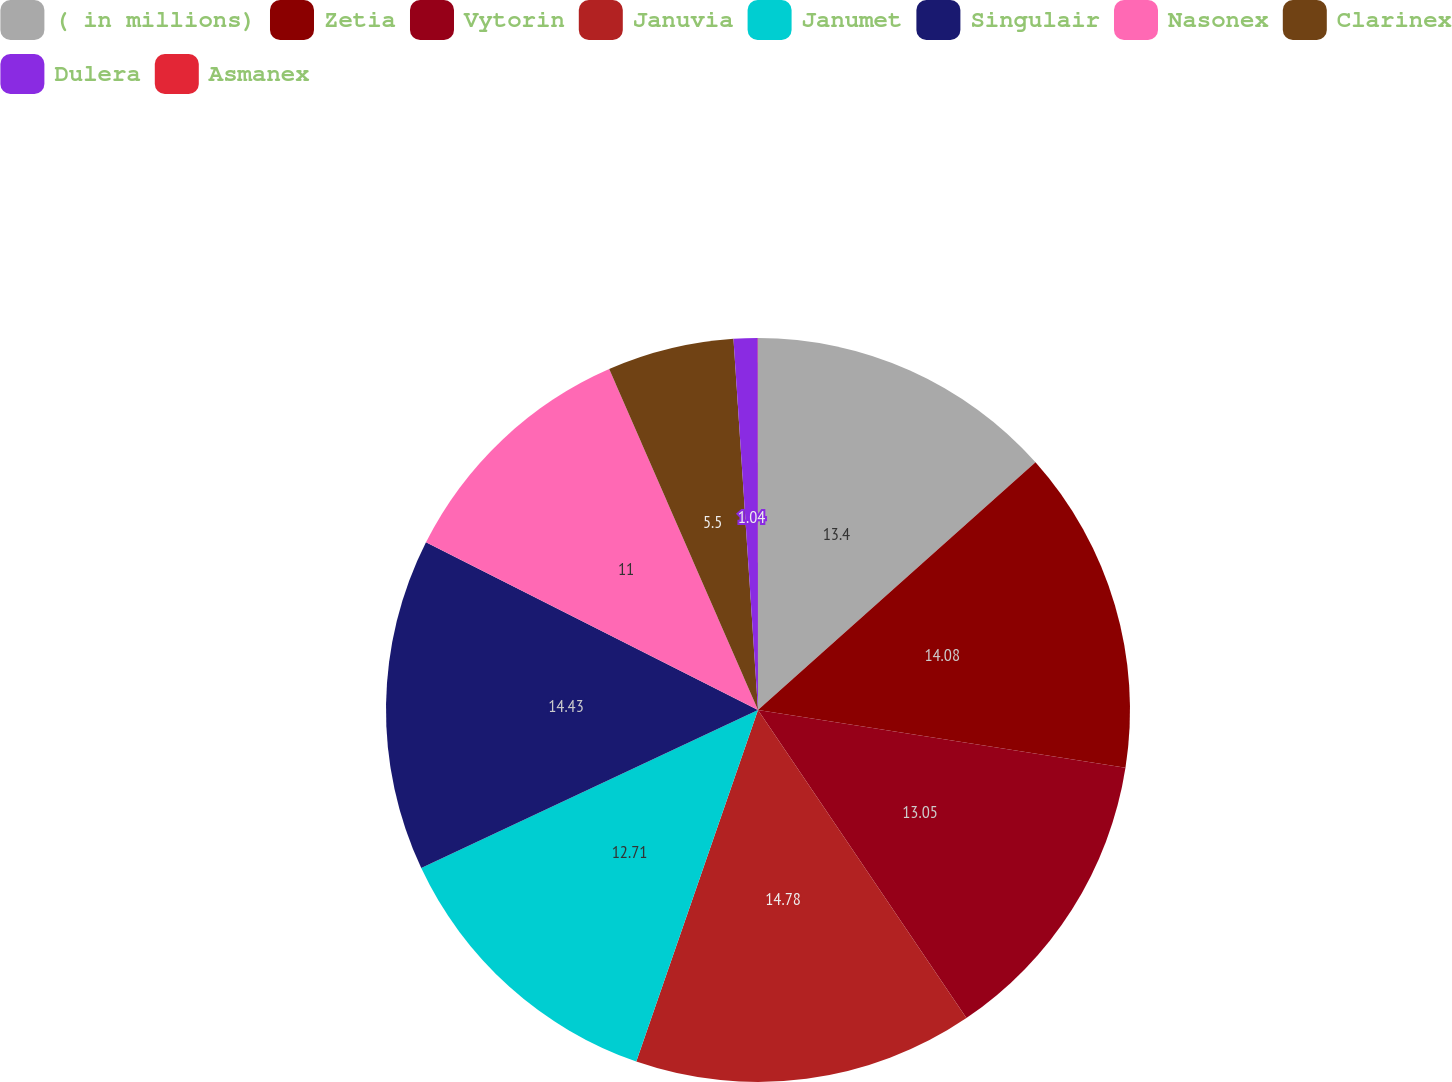Convert chart to OTSL. <chart><loc_0><loc_0><loc_500><loc_500><pie_chart><fcel>( in millions)<fcel>Zetia<fcel>Vytorin<fcel>Januvia<fcel>Janumet<fcel>Singulair<fcel>Nasonex<fcel>Clarinex<fcel>Dulera<fcel>Asmanex<nl><fcel>13.4%<fcel>14.08%<fcel>13.05%<fcel>14.77%<fcel>12.71%<fcel>14.43%<fcel>11.0%<fcel>5.5%<fcel>1.04%<fcel>0.01%<nl></chart> 